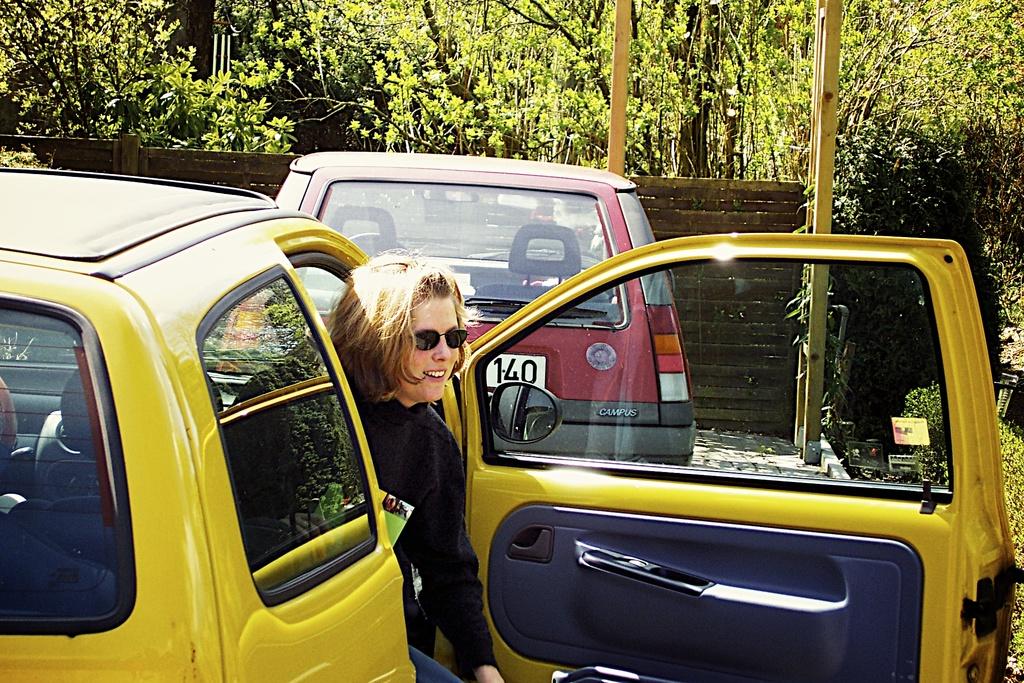What number is on the back of the red car?
Provide a short and direct response. 140. What model name is shown on the red car?
Provide a succinct answer. Campus. 